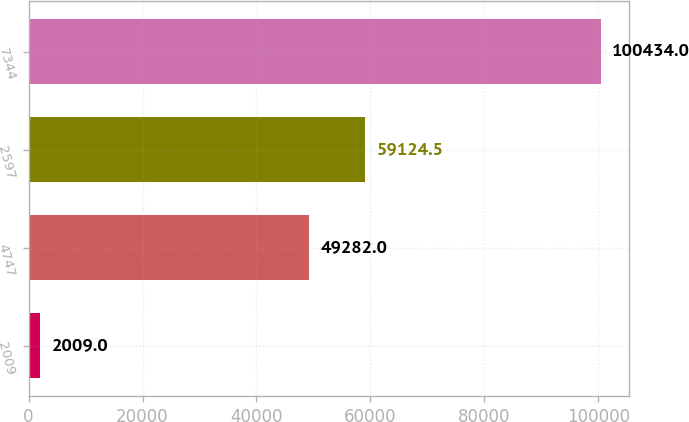<chart> <loc_0><loc_0><loc_500><loc_500><bar_chart><fcel>2009<fcel>4747<fcel>2597<fcel>7344<nl><fcel>2009<fcel>49282<fcel>59124.5<fcel>100434<nl></chart> 